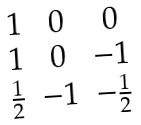Convert formula to latex. <formula><loc_0><loc_0><loc_500><loc_500>\begin{array} { c c c } 1 & 0 & 0 \\ 1 & 0 & - 1 \\ \frac { 1 } { 2 } & - 1 & - \frac { 1 } { 2 } \end{array}</formula> 